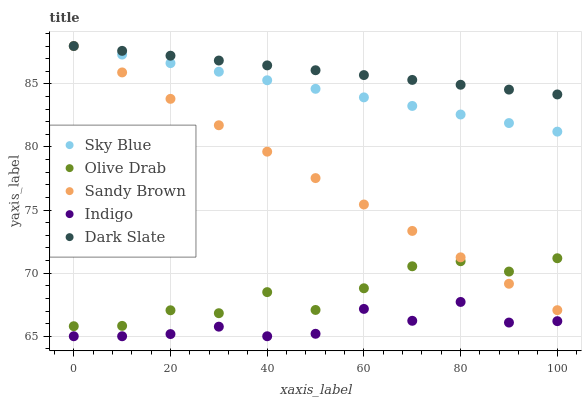Does Indigo have the minimum area under the curve?
Answer yes or no. Yes. Does Dark Slate have the maximum area under the curve?
Answer yes or no. Yes. Does Sandy Brown have the minimum area under the curve?
Answer yes or no. No. Does Sandy Brown have the maximum area under the curve?
Answer yes or no. No. Is Sky Blue the smoothest?
Answer yes or no. Yes. Is Olive Drab the roughest?
Answer yes or no. Yes. Is Sandy Brown the smoothest?
Answer yes or no. No. Is Sandy Brown the roughest?
Answer yes or no. No. Does Indigo have the lowest value?
Answer yes or no. Yes. Does Sandy Brown have the lowest value?
Answer yes or no. No. Does Dark Slate have the highest value?
Answer yes or no. Yes. Does Olive Drab have the highest value?
Answer yes or no. No. Is Indigo less than Dark Slate?
Answer yes or no. Yes. Is Sandy Brown greater than Indigo?
Answer yes or no. Yes. Does Sandy Brown intersect Olive Drab?
Answer yes or no. Yes. Is Sandy Brown less than Olive Drab?
Answer yes or no. No. Is Sandy Brown greater than Olive Drab?
Answer yes or no. No. Does Indigo intersect Dark Slate?
Answer yes or no. No. 